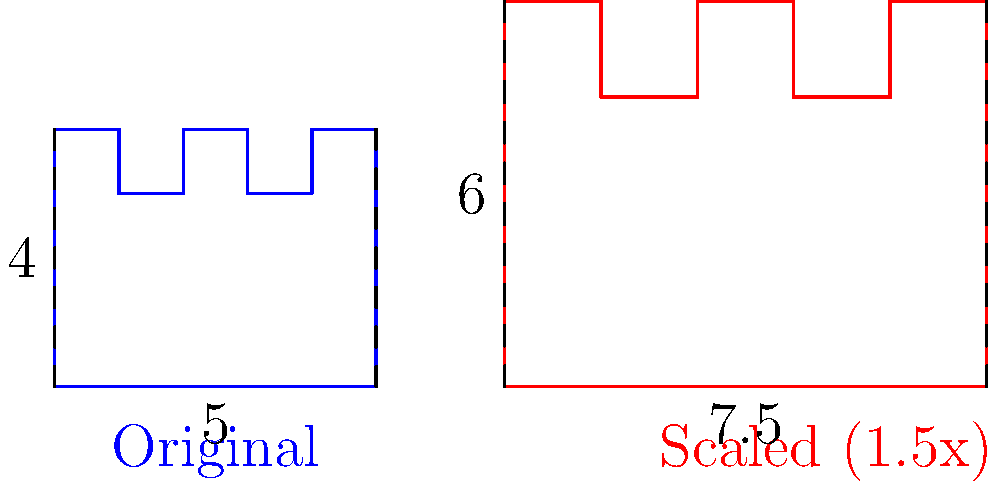As a supporter of the rabbi's charitable initiatives, you've been asked to help design a larger menorah for the community center. The original menorah design has a width of 5 units and a height of 4 units. If you need to scale up the menorah by a factor of 1.5, what will be the new dimensions (width and height) of the scaled menorah? To solve this problem, we need to apply the concept of scaling in transformational geometry. When an object is scaled by a factor $k$, all of its linear dimensions are multiplied by that factor. Let's go through this step-by-step:

1. Original dimensions:
   - Width: 5 units
   - Height: 4 units

2. Scaling factor: 1.5

3. To find the new dimensions, we multiply each original dimension by the scaling factor:

   New width = Original width $\times$ Scaling factor
              = $5 \times 1.5 = 7.5$ units

   New height = Original height $\times$ Scaling factor
               = $4 \times 1.5 = 6$ units

Therefore, the new dimensions of the scaled menorah are 7.5 units in width and 6 units in height.
Answer: 7.5 units wide, 6 units high 